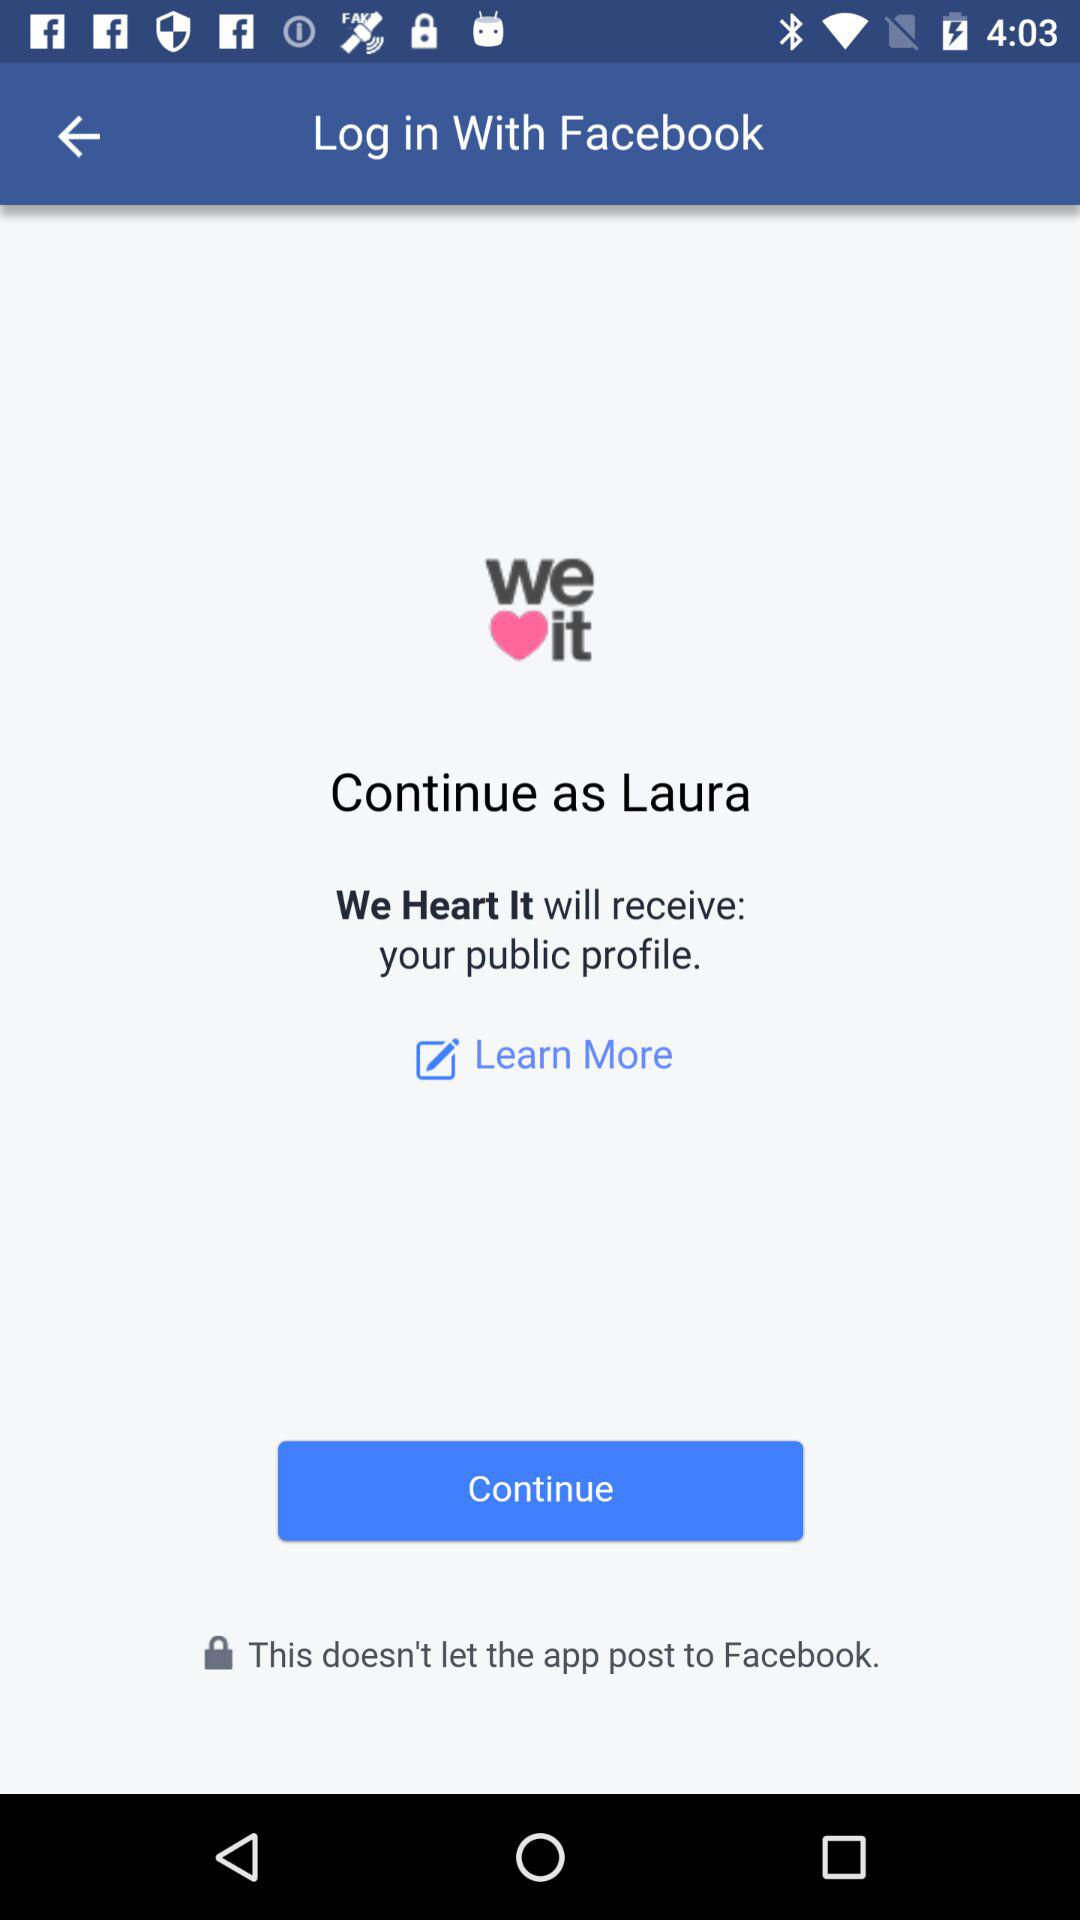What account am I using for login? The account is "Facebook". 